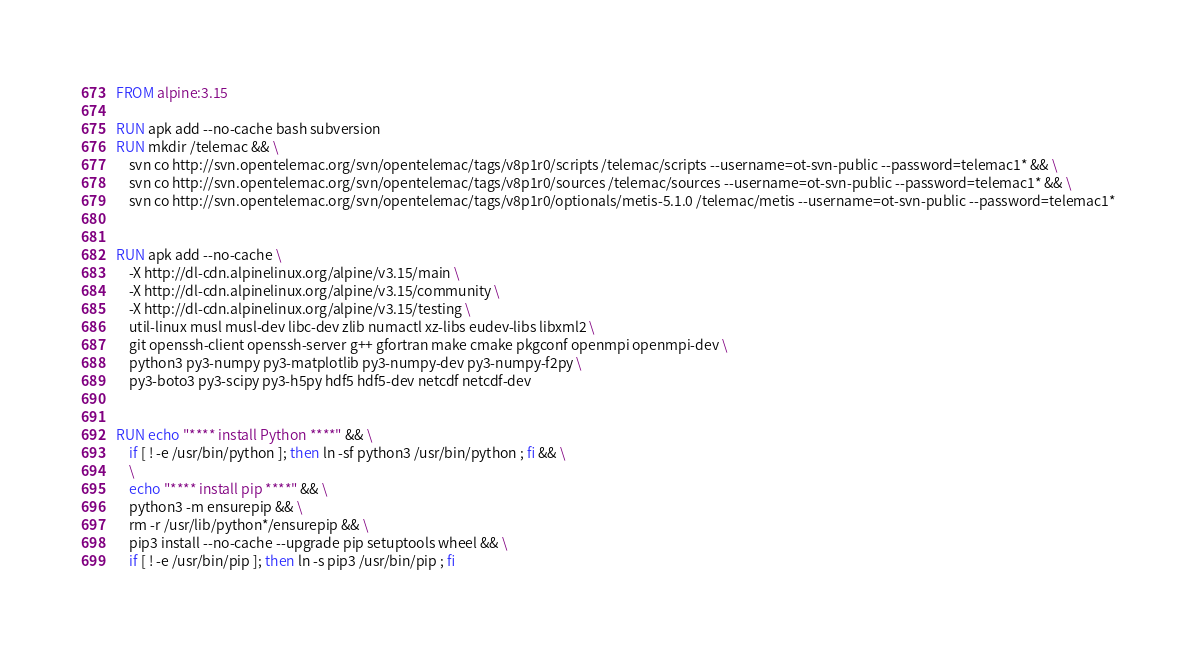Convert code to text. <code><loc_0><loc_0><loc_500><loc_500><_Dockerfile_>FROM alpine:3.15

RUN apk add --no-cache bash subversion
RUN mkdir /telemac && \
    svn co http://svn.opentelemac.org/svn/opentelemac/tags/v8p1r0/scripts /telemac/scripts --username=ot-svn-public --password=telemac1* && \
    svn co http://svn.opentelemac.org/svn/opentelemac/tags/v8p1r0/sources /telemac/sources --username=ot-svn-public --password=telemac1* && \
    svn co http://svn.opentelemac.org/svn/opentelemac/tags/v8p1r0/optionals/metis-5.1.0 /telemac/metis --username=ot-svn-public --password=telemac1*


RUN apk add --no-cache \
    -X http://dl-cdn.alpinelinux.org/alpine/v3.15/main \
    -X http://dl-cdn.alpinelinux.org/alpine/v3.15/community \
    -X http://dl-cdn.alpinelinux.org/alpine/v3.15/testing \
    util-linux musl musl-dev libc-dev zlib numactl xz-libs eudev-libs libxml2 \
    git openssh-client openssh-server g++ gfortran make cmake pkgconf openmpi openmpi-dev \
    python3 py3-numpy py3-matplotlib py3-numpy-dev py3-numpy-f2py \
    py3-boto3 py3-scipy py3-h5py hdf5 hdf5-dev netcdf netcdf-dev
    

RUN echo "**** install Python ****" && \
    if [ ! -e /usr/bin/python ]; then ln -sf python3 /usr/bin/python ; fi && \
    \
    echo "**** install pip ****" && \
    python3 -m ensurepip && \
    rm -r /usr/lib/python*/ensurepip && \
    pip3 install --no-cache --upgrade pip setuptools wheel && \
    if [ ! -e /usr/bin/pip ]; then ln -s pip3 /usr/bin/pip ; fi
</code> 